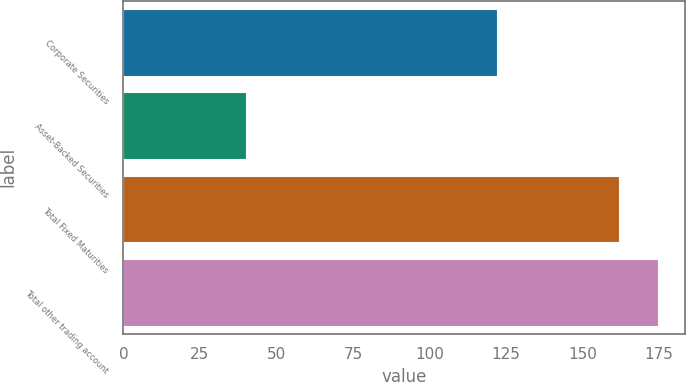<chart> <loc_0><loc_0><loc_500><loc_500><bar_chart><fcel>Corporate Securities<fcel>Asset-Backed Securities<fcel>Total Fixed Maturities<fcel>Total other trading account<nl><fcel>122<fcel>40<fcel>162<fcel>174.7<nl></chart> 